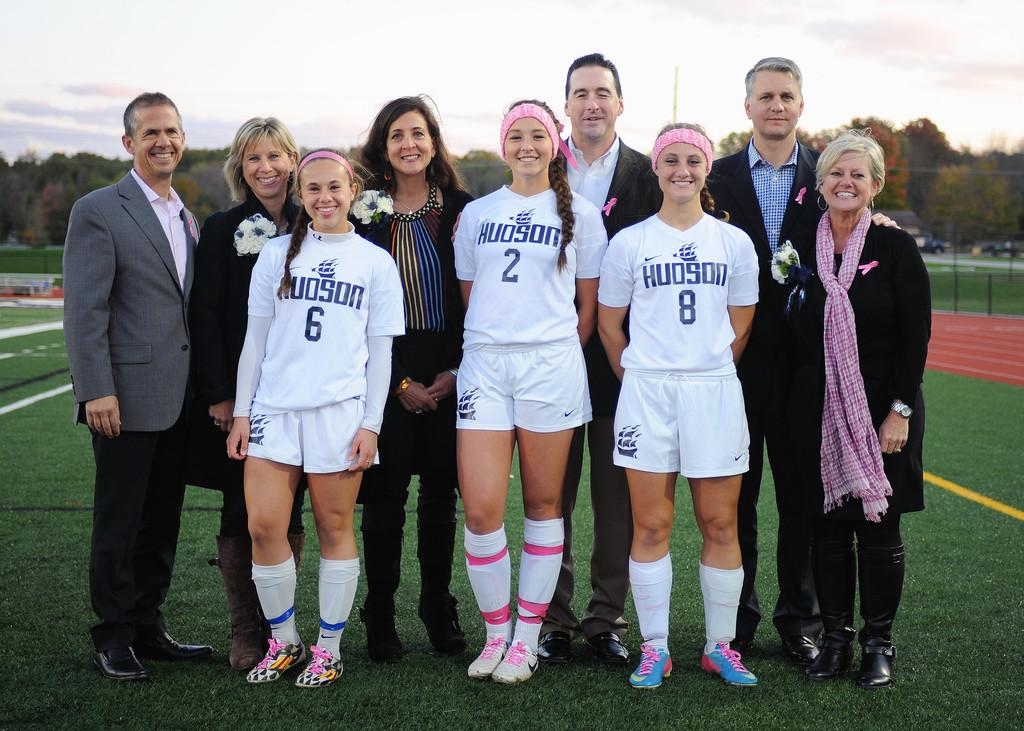Provide a one-sentence caption for the provided image. A group of people are standing in an athletic field and wearing uniforms that say Hudson. 